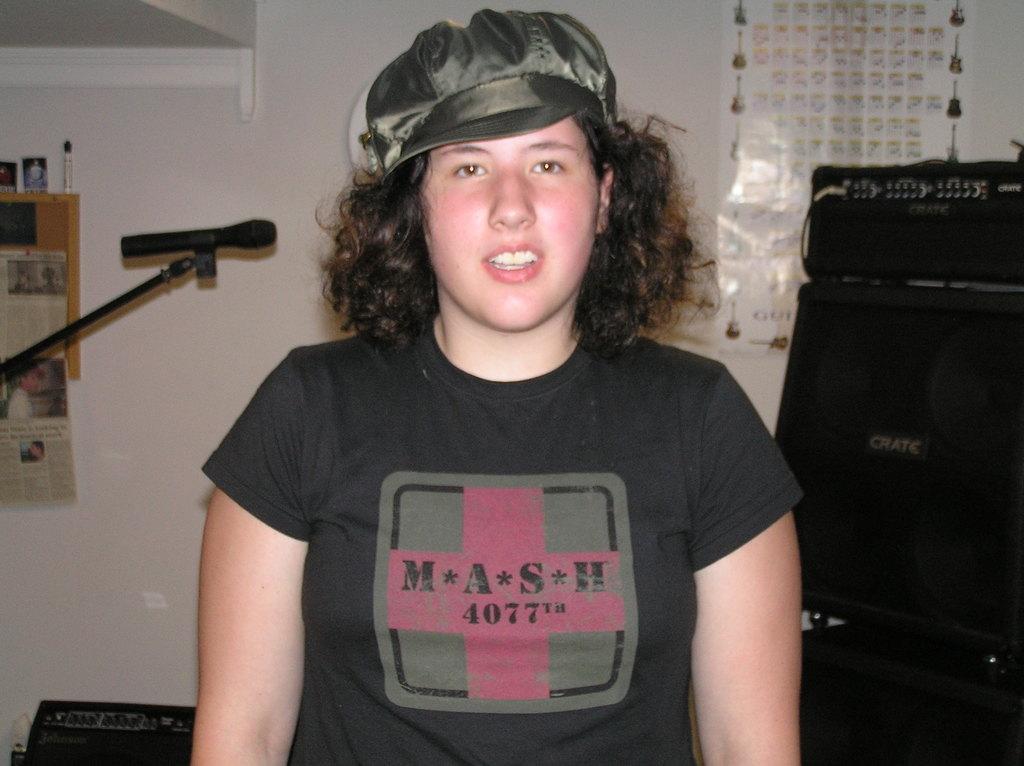Describe this image in one or two sentences. In this image we can see a person. Behind the person we can see a wall. On the right side, we can see a black object and a poster on the wall. On the left side, we can see a paper, mic with stand and few objects on a surface. 